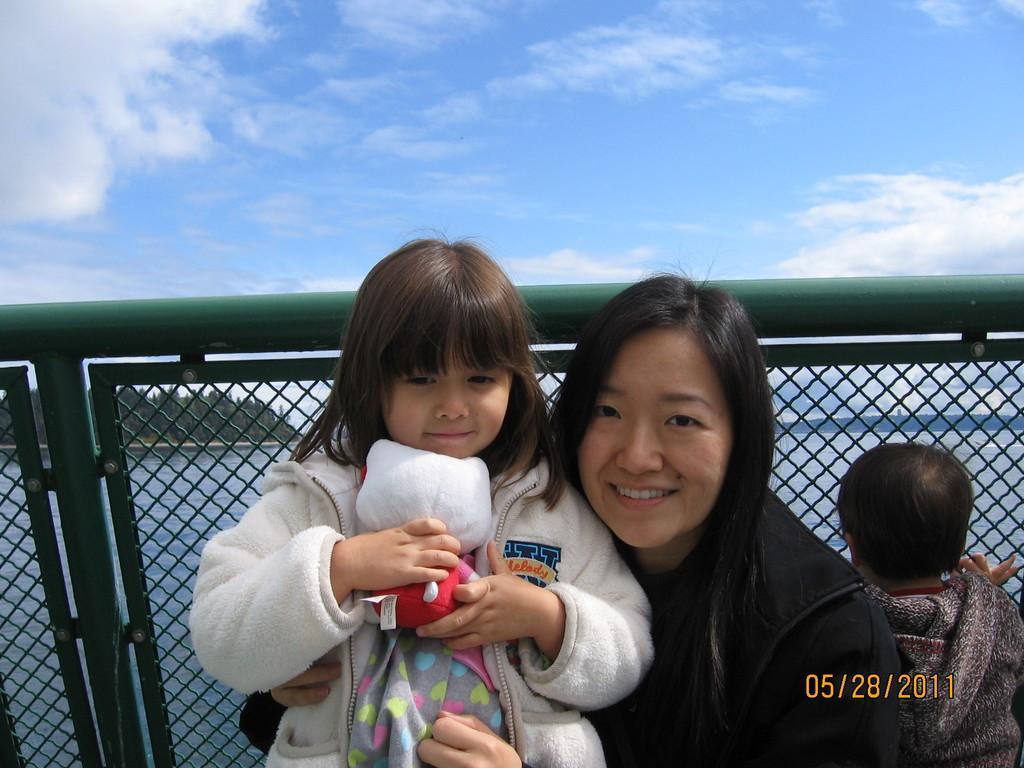Please provide a concise description of this image. In this image, we can see a person and kids in front of the safety barrier which is in front of the lake. There is a kid at the bottom of the image holding a doll with her hands. There is a date in the bottom right of the image. There are clouds in the sky. 